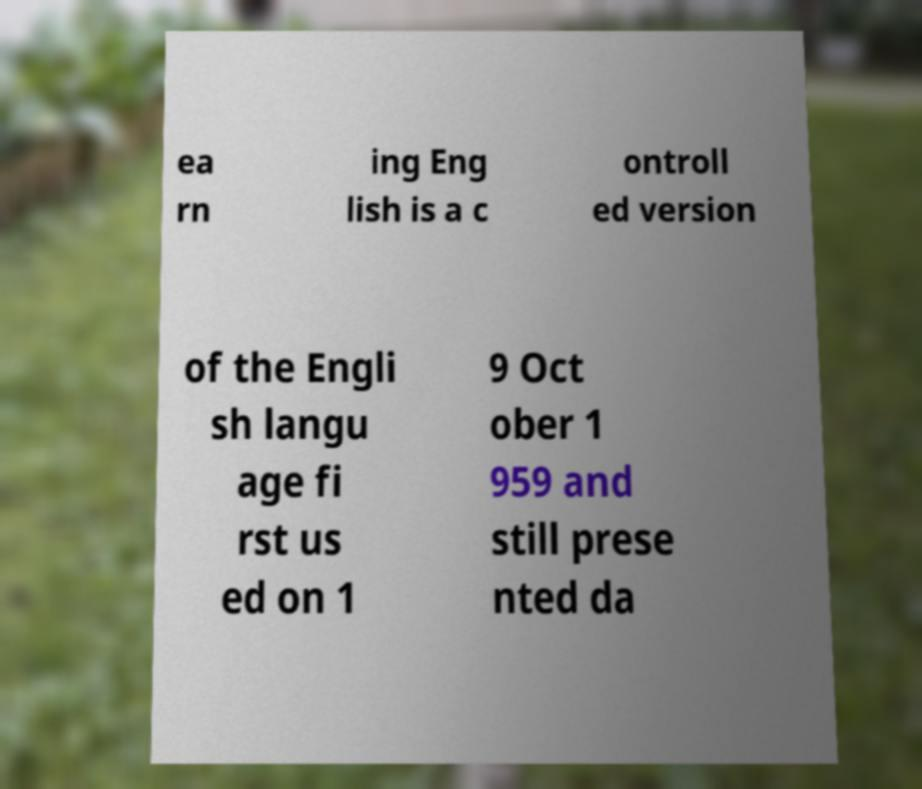For documentation purposes, I need the text within this image transcribed. Could you provide that? ea rn ing Eng lish is a c ontroll ed version of the Engli sh langu age fi rst us ed on 1 9 Oct ober 1 959 and still prese nted da 